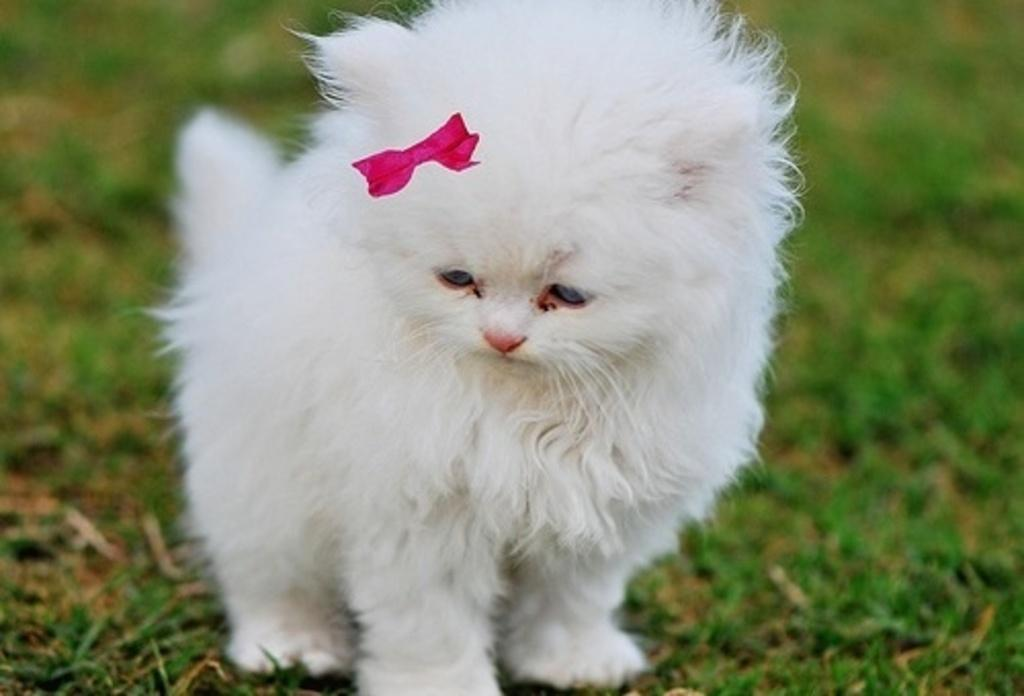What type of animal is in the image? The animal in the image is white in color. Can you describe the environment in the background of the image? There is grass on the ground in the background of the image. How much salt is visible in the image? There is no salt present in the image. What type of border is depicted in the image? There is no border present in the image. 